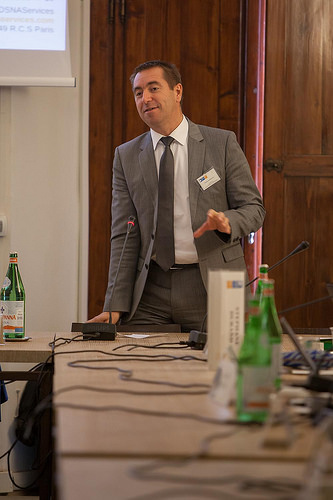<image>
Can you confirm if the man is behind the table? Yes. From this viewpoint, the man is positioned behind the table, with the table partially or fully occluding the man. Is there a man behind the bottle? No. The man is not behind the bottle. From this viewpoint, the man appears to be positioned elsewhere in the scene. 